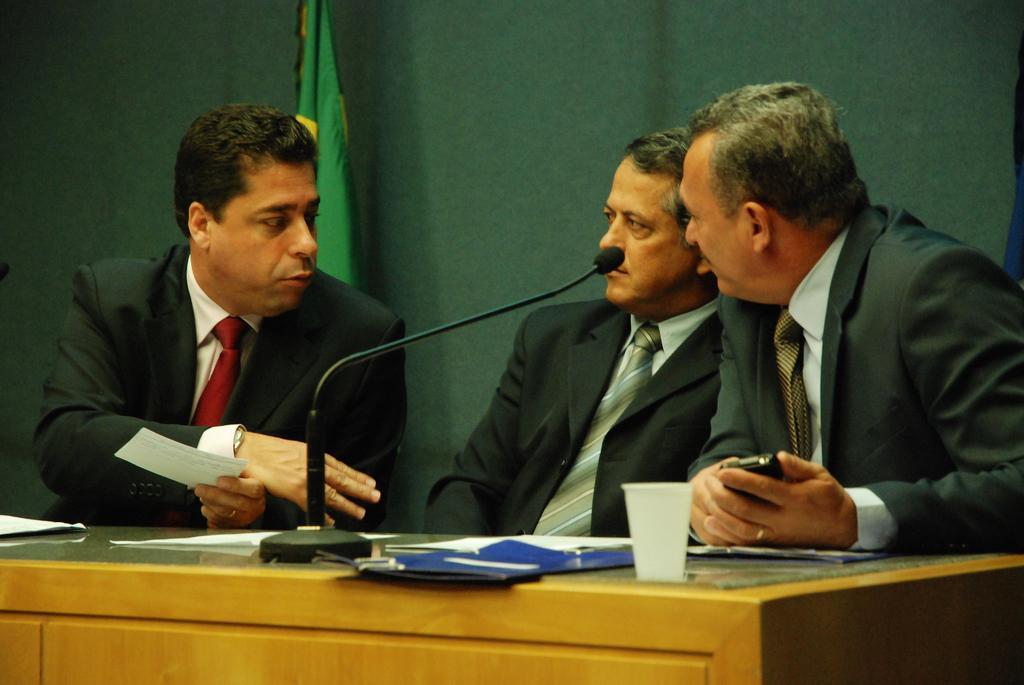Describe this image in one or two sentences. In this image, we can see people wearing coats and ties and some are holding objects. In the background, there is a flag and we can see a curtain. At the bottom, we can see papers, a mic, a glass and some other objects on the stand. 